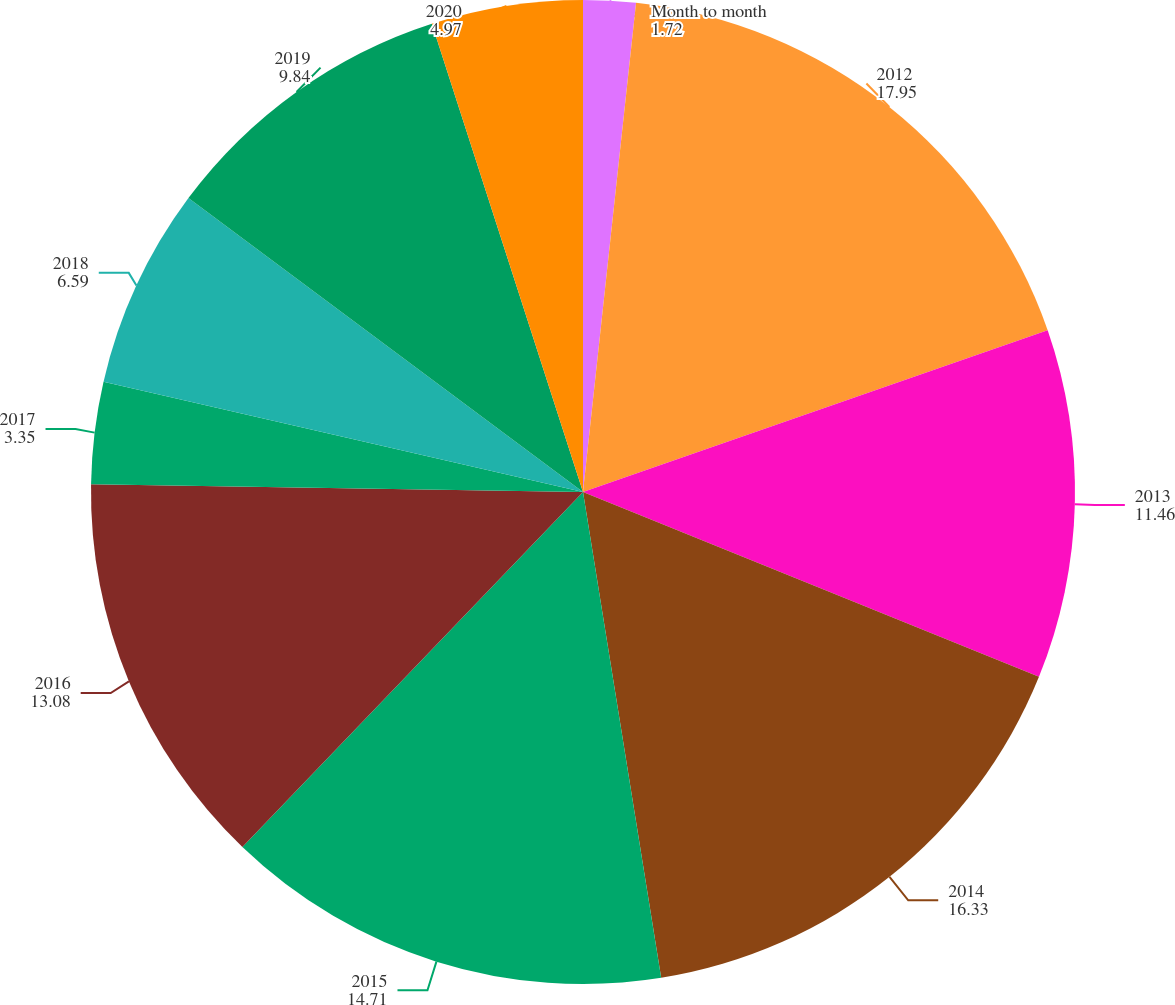<chart> <loc_0><loc_0><loc_500><loc_500><pie_chart><fcel>Month to month<fcel>2012<fcel>2013<fcel>2014<fcel>2015<fcel>2016<fcel>2017<fcel>2018<fcel>2019<fcel>2020<nl><fcel>1.72%<fcel>17.95%<fcel>11.46%<fcel>16.33%<fcel>14.71%<fcel>13.08%<fcel>3.35%<fcel>6.59%<fcel>9.84%<fcel>4.97%<nl></chart> 